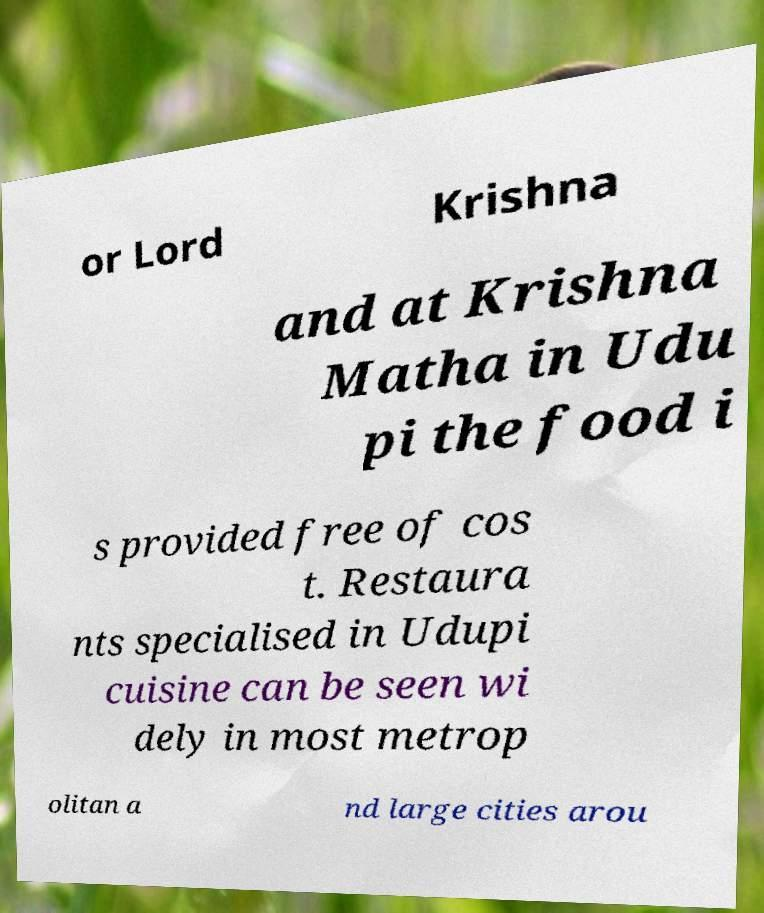Could you extract and type out the text from this image? or Lord Krishna and at Krishna Matha in Udu pi the food i s provided free of cos t. Restaura nts specialised in Udupi cuisine can be seen wi dely in most metrop olitan a nd large cities arou 